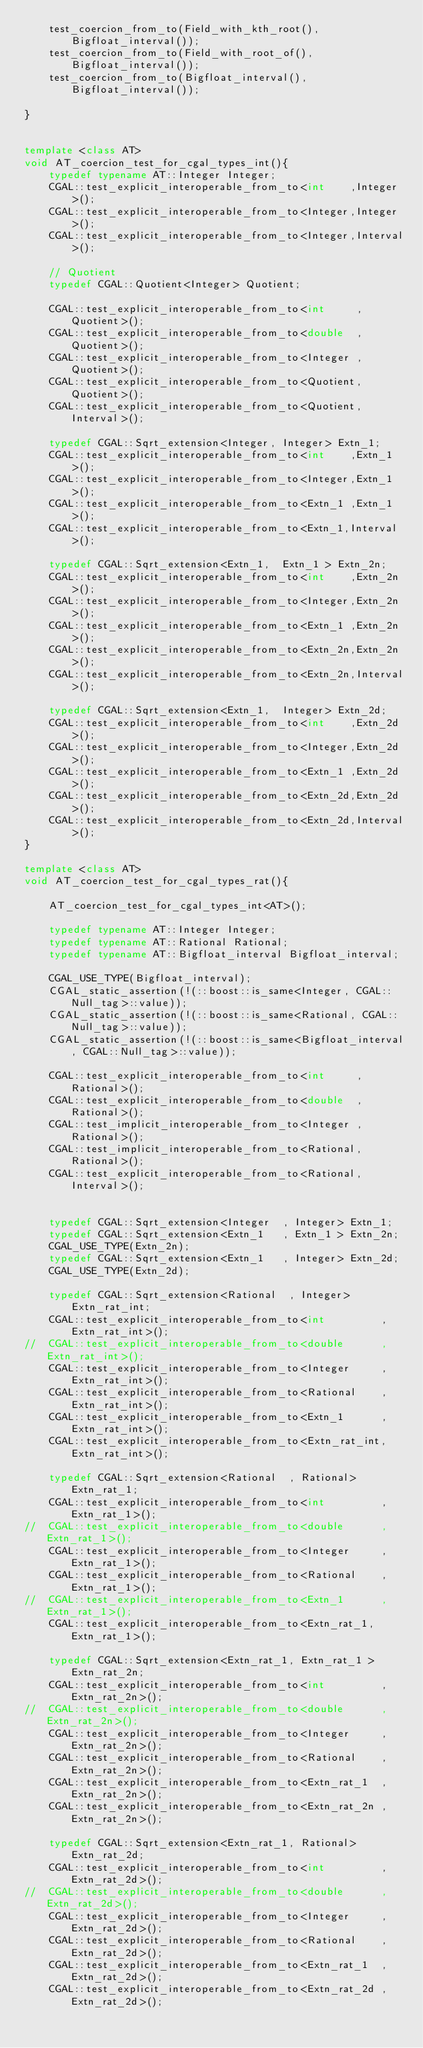Convert code to text. <code><loc_0><loc_0><loc_500><loc_500><_C++_>    test_coercion_from_to(Field_with_kth_root(),Bigfloat_interval());
    test_coercion_from_to(Field_with_root_of(),Bigfloat_interval());
    test_coercion_from_to(Bigfloat_interval(),Bigfloat_interval());

}


template <class AT>
void AT_coercion_test_for_cgal_types_int(){
    typedef typename AT::Integer Integer;
    CGAL::test_explicit_interoperable_from_to<int    ,Integer>();
    CGAL::test_explicit_interoperable_from_to<Integer,Integer>();
    CGAL::test_explicit_interoperable_from_to<Integer,Interval>();

    // Quotient
    typedef CGAL::Quotient<Integer> Quotient;

    CGAL::test_explicit_interoperable_from_to<int     ,Quotient>();
    CGAL::test_explicit_interoperable_from_to<double  ,Quotient>();
    CGAL::test_explicit_interoperable_from_to<Integer ,Quotient>();
    CGAL::test_explicit_interoperable_from_to<Quotient,Quotient>();
    CGAL::test_explicit_interoperable_from_to<Quotient,Interval>();

    typedef CGAL::Sqrt_extension<Integer, Integer> Extn_1;
    CGAL::test_explicit_interoperable_from_to<int    ,Extn_1>();
    CGAL::test_explicit_interoperable_from_to<Integer,Extn_1>();
    CGAL::test_explicit_interoperable_from_to<Extn_1 ,Extn_1>();
    CGAL::test_explicit_interoperable_from_to<Extn_1,Interval>();

    typedef CGAL::Sqrt_extension<Extn_1,  Extn_1 > Extn_2n;
    CGAL::test_explicit_interoperable_from_to<int    ,Extn_2n>();
    CGAL::test_explicit_interoperable_from_to<Integer,Extn_2n>();
    CGAL::test_explicit_interoperable_from_to<Extn_1 ,Extn_2n>();
    CGAL::test_explicit_interoperable_from_to<Extn_2n,Extn_2n>();
    CGAL::test_explicit_interoperable_from_to<Extn_2n,Interval>();

    typedef CGAL::Sqrt_extension<Extn_1,  Integer> Extn_2d;
    CGAL::test_explicit_interoperable_from_to<int    ,Extn_2d>();
    CGAL::test_explicit_interoperable_from_to<Integer,Extn_2d>();
    CGAL::test_explicit_interoperable_from_to<Extn_1 ,Extn_2d>();
    CGAL::test_explicit_interoperable_from_to<Extn_2d,Extn_2d>();
    CGAL::test_explicit_interoperable_from_to<Extn_2d,Interval>();
}

template <class AT>
void AT_coercion_test_for_cgal_types_rat(){

    AT_coercion_test_for_cgal_types_int<AT>();

    typedef typename AT::Integer Integer;
    typedef typename AT::Rational Rational;
    typedef typename AT::Bigfloat_interval Bigfloat_interval;

    CGAL_USE_TYPE(Bigfloat_interval);
    CGAL_static_assertion(!(::boost::is_same<Integer, CGAL::Null_tag>::value));
    CGAL_static_assertion(!(::boost::is_same<Rational, CGAL::Null_tag>::value));
    CGAL_static_assertion(!(::boost::is_same<Bigfloat_interval, CGAL::Null_tag>::value));

    CGAL::test_explicit_interoperable_from_to<int     ,Rational>();
    CGAL::test_explicit_interoperable_from_to<double  ,Rational>();
    CGAL::test_implicit_interoperable_from_to<Integer ,Rational>();
    CGAL::test_implicit_interoperable_from_to<Rational,Rational>();
    CGAL::test_explicit_interoperable_from_to<Rational,Interval>();


    typedef CGAL::Sqrt_extension<Integer  , Integer> Extn_1;
    typedef CGAL::Sqrt_extension<Extn_1   , Extn_1 > Extn_2n;
    CGAL_USE_TYPE(Extn_2n);
    typedef CGAL::Sqrt_extension<Extn_1   , Integer> Extn_2d;
    CGAL_USE_TYPE(Extn_2d);

    typedef CGAL::Sqrt_extension<Rational  , Integer> Extn_rat_int;
    CGAL::test_explicit_interoperable_from_to<int         ,Extn_rat_int>();
//  CGAL::test_explicit_interoperable_from_to<double      ,Extn_rat_int>();
    CGAL::test_explicit_interoperable_from_to<Integer     ,Extn_rat_int>();
    CGAL::test_explicit_interoperable_from_to<Rational    ,Extn_rat_int>();
    CGAL::test_explicit_interoperable_from_to<Extn_1      ,Extn_rat_int>();
    CGAL::test_explicit_interoperable_from_to<Extn_rat_int,Extn_rat_int>();

    typedef CGAL::Sqrt_extension<Rational  , Rational> Extn_rat_1;
    CGAL::test_explicit_interoperable_from_to<int         ,Extn_rat_1>();
//  CGAL::test_explicit_interoperable_from_to<double      ,Extn_rat_1>();
    CGAL::test_explicit_interoperable_from_to<Integer     ,Extn_rat_1>();
    CGAL::test_explicit_interoperable_from_to<Rational    ,Extn_rat_1>();
//  CGAL::test_explicit_interoperable_from_to<Extn_1      ,Extn_rat_1>();
    CGAL::test_explicit_interoperable_from_to<Extn_rat_1,Extn_rat_1>();

    typedef CGAL::Sqrt_extension<Extn_rat_1, Extn_rat_1 > Extn_rat_2n;
    CGAL::test_explicit_interoperable_from_to<int         ,Extn_rat_2n>();
//  CGAL::test_explicit_interoperable_from_to<double      ,Extn_rat_2n>();
    CGAL::test_explicit_interoperable_from_to<Integer     ,Extn_rat_2n>();
    CGAL::test_explicit_interoperable_from_to<Rational    ,Extn_rat_2n>();
    CGAL::test_explicit_interoperable_from_to<Extn_rat_1  ,Extn_rat_2n>();
    CGAL::test_explicit_interoperable_from_to<Extn_rat_2n ,Extn_rat_2n>();

    typedef CGAL::Sqrt_extension<Extn_rat_1, Rational> Extn_rat_2d;
    CGAL::test_explicit_interoperable_from_to<int         ,Extn_rat_2d>();
//  CGAL::test_explicit_interoperable_from_to<double      ,Extn_rat_2d>();
    CGAL::test_explicit_interoperable_from_to<Integer     ,Extn_rat_2d>();
    CGAL::test_explicit_interoperable_from_to<Rational    ,Extn_rat_2d>();
    CGAL::test_explicit_interoperable_from_to<Extn_rat_1  ,Extn_rat_2d>();
    CGAL::test_explicit_interoperable_from_to<Extn_rat_2d ,Extn_rat_2d>();</code> 